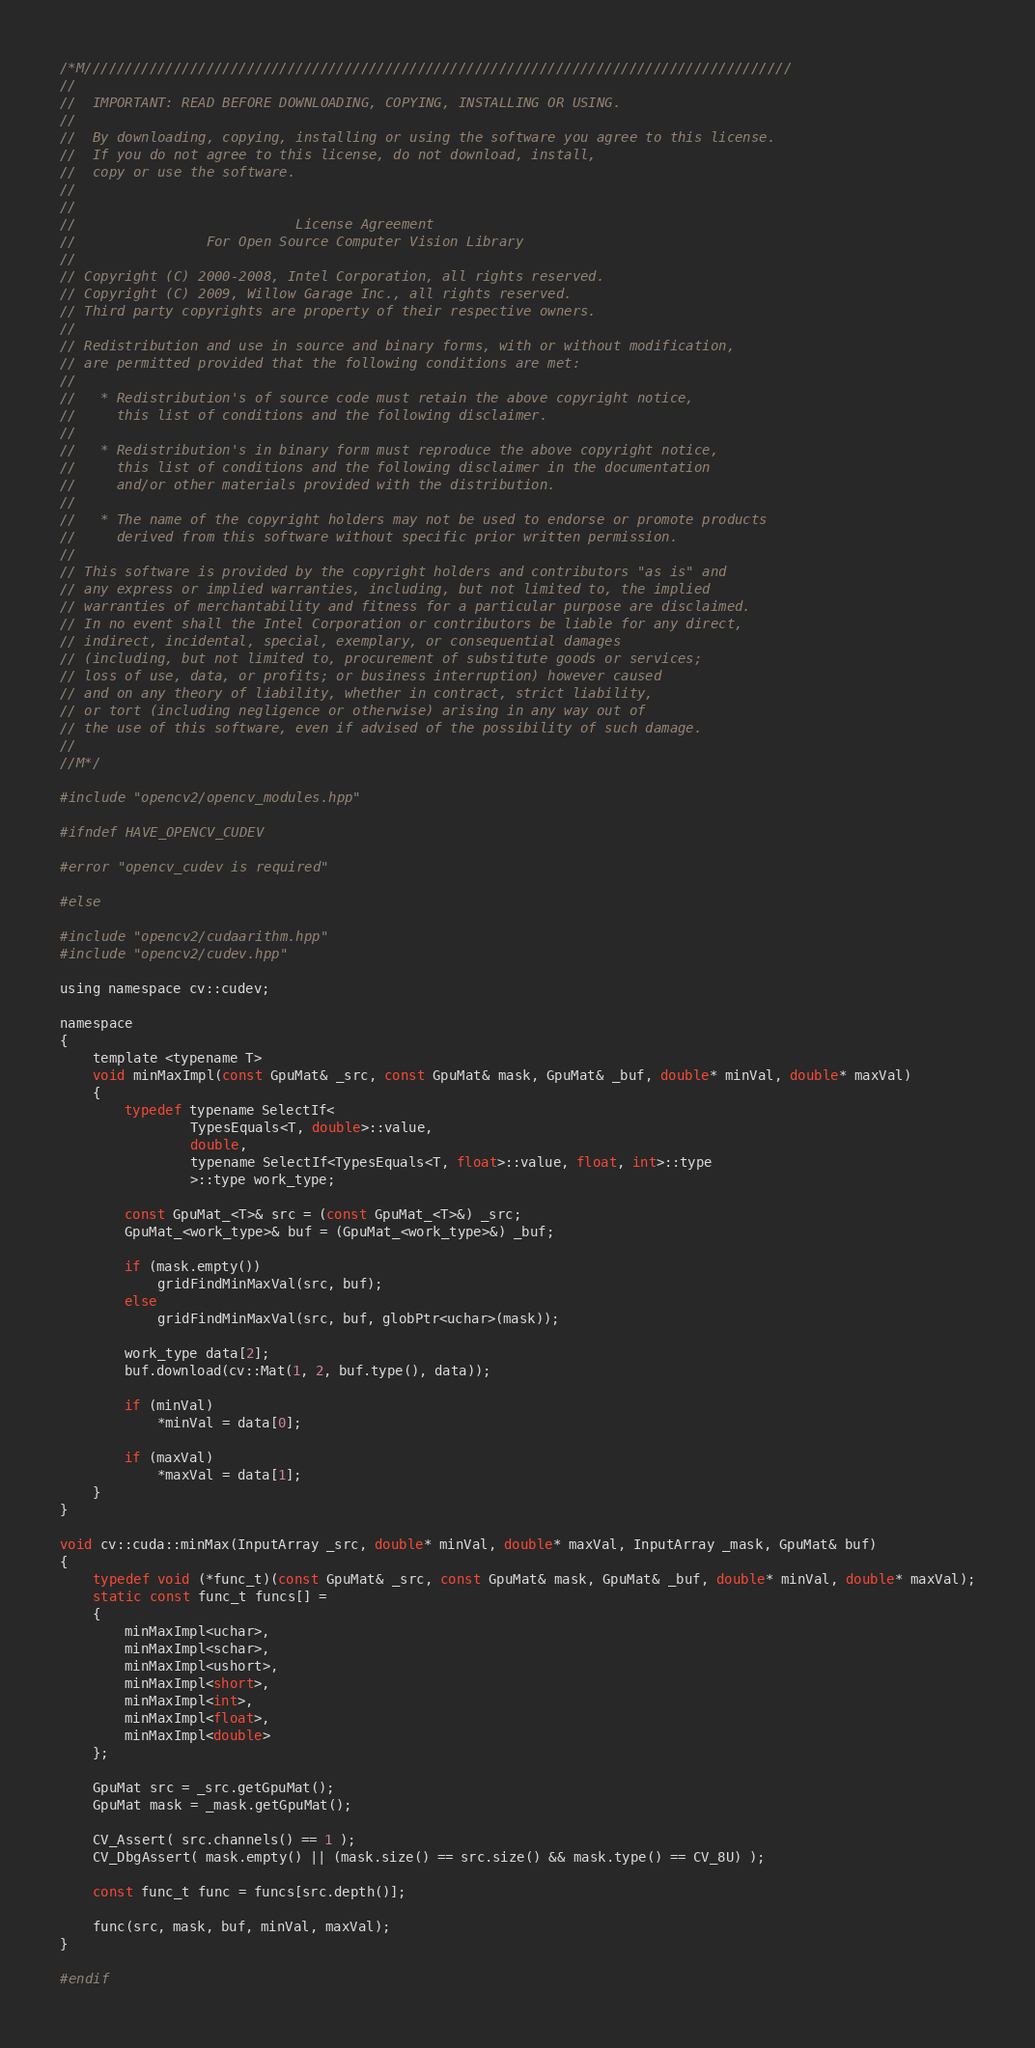<code> <loc_0><loc_0><loc_500><loc_500><_Cuda_>/*M///////////////////////////////////////////////////////////////////////////////////////
//
//  IMPORTANT: READ BEFORE DOWNLOADING, COPYING, INSTALLING OR USING.
//
//  By downloading, copying, installing or using the software you agree to this license.
//  If you do not agree to this license, do not download, install,
//  copy or use the software.
//
//
//                           License Agreement
//                For Open Source Computer Vision Library
//
// Copyright (C) 2000-2008, Intel Corporation, all rights reserved.
// Copyright (C) 2009, Willow Garage Inc., all rights reserved.
// Third party copyrights are property of their respective owners.
//
// Redistribution and use in source and binary forms, with or without modification,
// are permitted provided that the following conditions are met:
//
//   * Redistribution's of source code must retain the above copyright notice,
//     this list of conditions and the following disclaimer.
//
//   * Redistribution's in binary form must reproduce the above copyright notice,
//     this list of conditions and the following disclaimer in the documentation
//     and/or other materials provided with the distribution.
//
//   * The name of the copyright holders may not be used to endorse or promote products
//     derived from this software without specific prior written permission.
//
// This software is provided by the copyright holders and contributors "as is" and
// any express or implied warranties, including, but not limited to, the implied
// warranties of merchantability and fitness for a particular purpose are disclaimed.
// In no event shall the Intel Corporation or contributors be liable for any direct,
// indirect, incidental, special, exemplary, or consequential damages
// (including, but not limited to, procurement of substitute goods or services;
// loss of use, data, or profits; or business interruption) however caused
// and on any theory of liability, whether in contract, strict liability,
// or tort (including negligence or otherwise) arising in any way out of
// the use of this software, even if advised of the possibility of such damage.
//
//M*/

#include "opencv2/opencv_modules.hpp"

#ifndef HAVE_OPENCV_CUDEV

#error "opencv_cudev is required"

#else

#include "opencv2/cudaarithm.hpp"
#include "opencv2/cudev.hpp"

using namespace cv::cudev;

namespace
{
    template <typename T>
    void minMaxImpl(const GpuMat& _src, const GpuMat& mask, GpuMat& _buf, double* minVal, double* maxVal)
    {
        typedef typename SelectIf<
                TypesEquals<T, double>::value,
                double,
                typename SelectIf<TypesEquals<T, float>::value, float, int>::type
                >::type work_type;

        const GpuMat_<T>& src = (const GpuMat_<T>&) _src;
        GpuMat_<work_type>& buf = (GpuMat_<work_type>&) _buf;

        if (mask.empty())
            gridFindMinMaxVal(src, buf);
        else
            gridFindMinMaxVal(src, buf, globPtr<uchar>(mask));

        work_type data[2];
        buf.download(cv::Mat(1, 2, buf.type(), data));

        if (minVal)
            *minVal = data[0];

        if (maxVal)
            *maxVal = data[1];
    }
}

void cv::cuda::minMax(InputArray _src, double* minVal, double* maxVal, InputArray _mask, GpuMat& buf)
{
    typedef void (*func_t)(const GpuMat& _src, const GpuMat& mask, GpuMat& _buf, double* minVal, double* maxVal);
    static const func_t funcs[] =
    {
        minMaxImpl<uchar>,
        minMaxImpl<schar>,
        minMaxImpl<ushort>,
        minMaxImpl<short>,
        minMaxImpl<int>,
        minMaxImpl<float>,
        minMaxImpl<double>
    };

    GpuMat src = _src.getGpuMat();
    GpuMat mask = _mask.getGpuMat();

    CV_Assert( src.channels() == 1 );
    CV_DbgAssert( mask.empty() || (mask.size() == src.size() && mask.type() == CV_8U) );

    const func_t func = funcs[src.depth()];

    func(src, mask, buf, minVal, maxVal);
}

#endif
</code> 